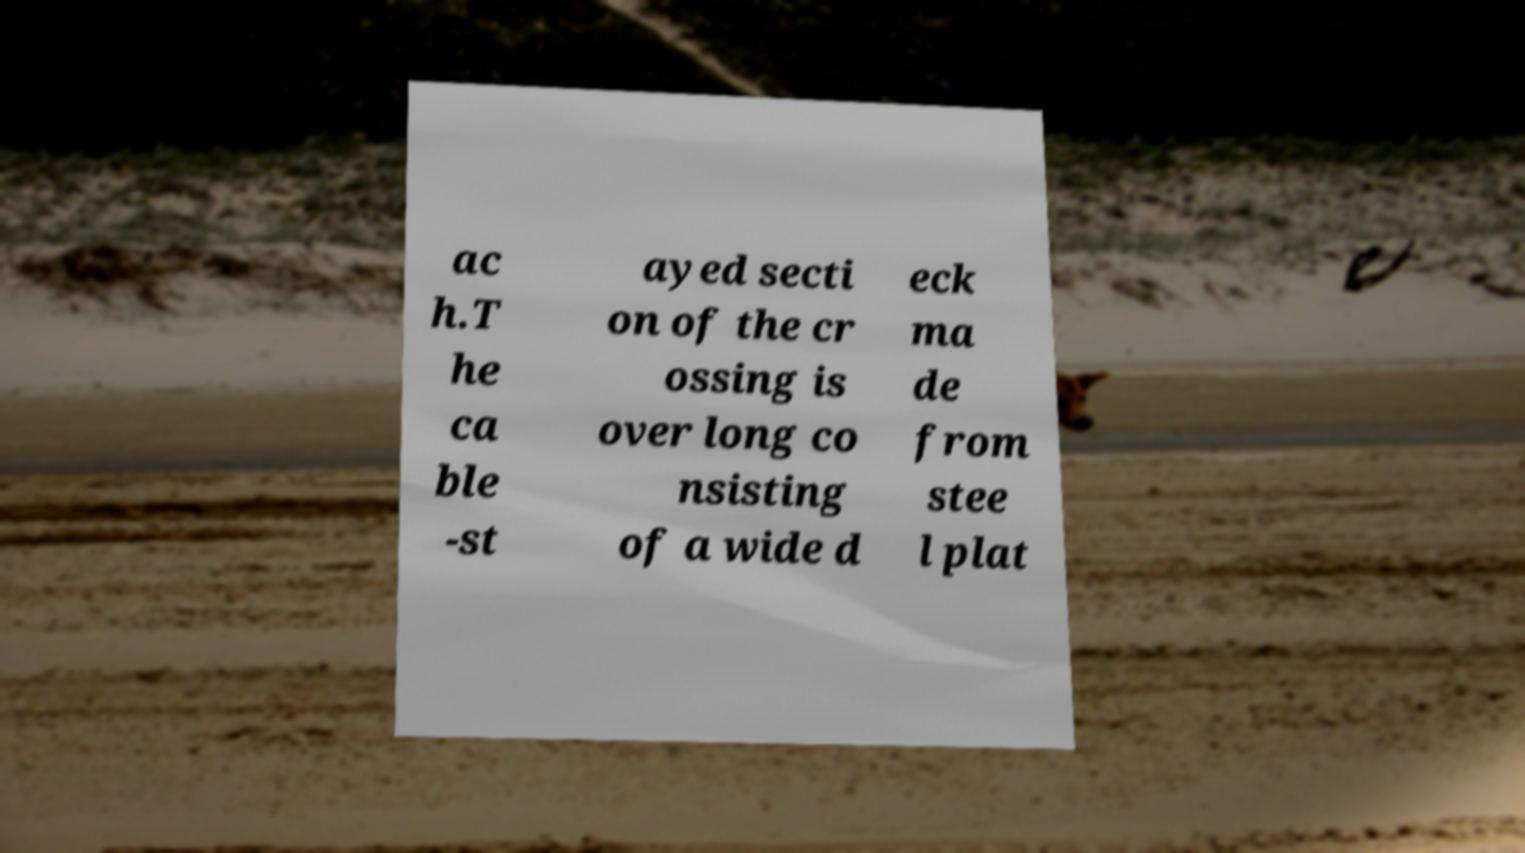There's text embedded in this image that I need extracted. Can you transcribe it verbatim? ac h.T he ca ble -st ayed secti on of the cr ossing is over long co nsisting of a wide d eck ma de from stee l plat 